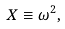Convert formula to latex. <formula><loc_0><loc_0><loc_500><loc_500>X \equiv \omega ^ { 2 } ,</formula> 